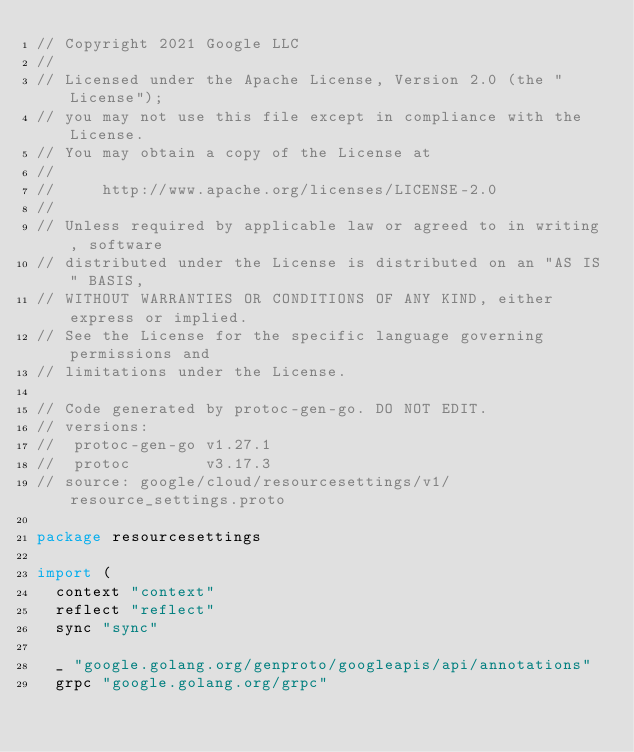Convert code to text. <code><loc_0><loc_0><loc_500><loc_500><_Go_>// Copyright 2021 Google LLC
//
// Licensed under the Apache License, Version 2.0 (the "License");
// you may not use this file except in compliance with the License.
// You may obtain a copy of the License at
//
//     http://www.apache.org/licenses/LICENSE-2.0
//
// Unless required by applicable law or agreed to in writing, software
// distributed under the License is distributed on an "AS IS" BASIS,
// WITHOUT WARRANTIES OR CONDITIONS OF ANY KIND, either express or implied.
// See the License for the specific language governing permissions and
// limitations under the License.

// Code generated by protoc-gen-go. DO NOT EDIT.
// versions:
// 	protoc-gen-go v1.27.1
// 	protoc        v3.17.3
// source: google/cloud/resourcesettings/v1/resource_settings.proto

package resourcesettings

import (
	context "context"
	reflect "reflect"
	sync "sync"

	_ "google.golang.org/genproto/googleapis/api/annotations"
	grpc "google.golang.org/grpc"</code> 